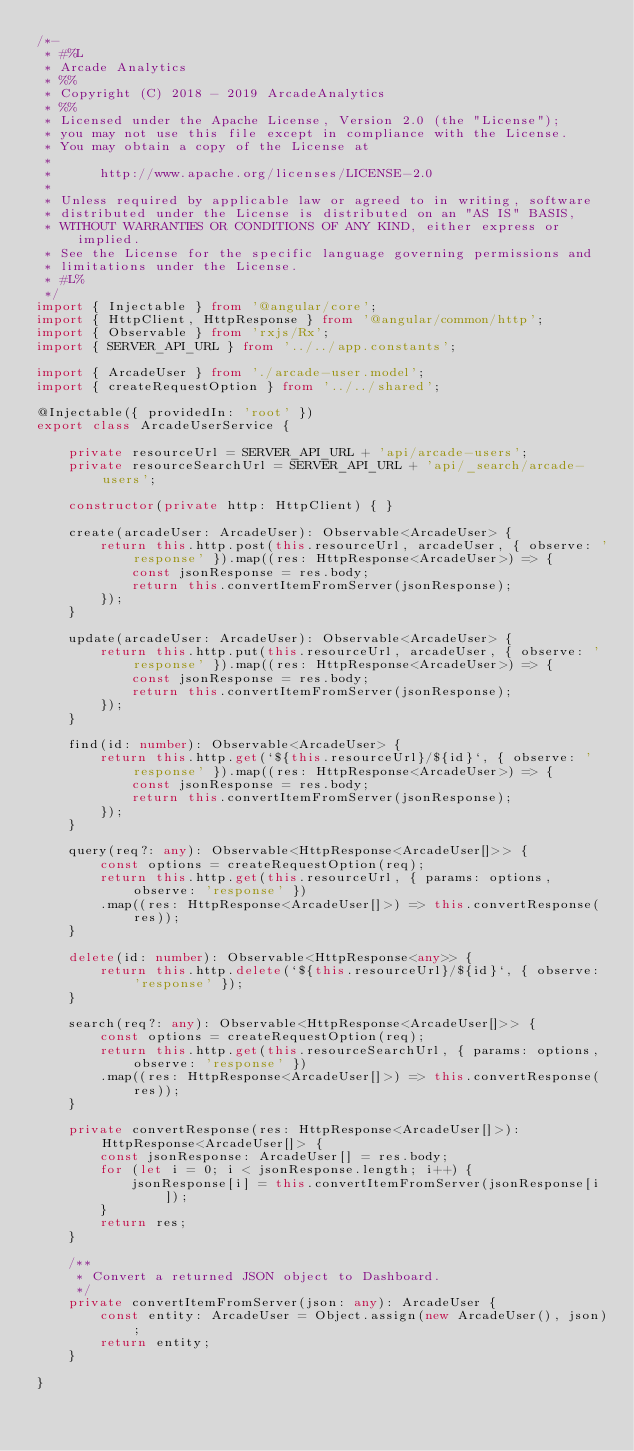<code> <loc_0><loc_0><loc_500><loc_500><_TypeScript_>/*-
 * #%L
 * Arcade Analytics
 * %%
 * Copyright (C) 2018 - 2019 ArcadeAnalytics
 * %%
 * Licensed under the Apache License, Version 2.0 (the "License");
 * you may not use this file except in compliance with the License.
 * You may obtain a copy of the License at
 *
 *      http://www.apache.org/licenses/LICENSE-2.0
 *
 * Unless required by applicable law or agreed to in writing, software
 * distributed under the License is distributed on an "AS IS" BASIS,
 * WITHOUT WARRANTIES OR CONDITIONS OF ANY KIND, either express or implied.
 * See the License for the specific language governing permissions and
 * limitations under the License.
 * #L%
 */
import { Injectable } from '@angular/core';
import { HttpClient, HttpResponse } from '@angular/common/http';
import { Observable } from 'rxjs/Rx';
import { SERVER_API_URL } from '../../app.constants';

import { ArcadeUser } from './arcade-user.model';
import { createRequestOption } from '../../shared';

@Injectable({ providedIn: 'root' })
export class ArcadeUserService {

    private resourceUrl = SERVER_API_URL + 'api/arcade-users';
    private resourceSearchUrl = SERVER_API_URL + 'api/_search/arcade-users';

    constructor(private http: HttpClient) { }

    create(arcadeUser: ArcadeUser): Observable<ArcadeUser> {
        return this.http.post(this.resourceUrl, arcadeUser, { observe: 'response' }).map((res: HttpResponse<ArcadeUser>) => {
            const jsonResponse = res.body;
            return this.convertItemFromServer(jsonResponse);
        });
    }

    update(arcadeUser: ArcadeUser): Observable<ArcadeUser> {
        return this.http.put(this.resourceUrl, arcadeUser, { observe: 'response' }).map((res: HttpResponse<ArcadeUser>) => {
            const jsonResponse = res.body;
            return this.convertItemFromServer(jsonResponse);
        });
    }

    find(id: number): Observable<ArcadeUser> {
        return this.http.get(`${this.resourceUrl}/${id}`, { observe: 'response' }).map((res: HttpResponse<ArcadeUser>) => {
            const jsonResponse = res.body;
            return this.convertItemFromServer(jsonResponse);
        });
    }

    query(req?: any): Observable<HttpResponse<ArcadeUser[]>> {
        const options = createRequestOption(req);
        return this.http.get(this.resourceUrl, { params: options, observe: 'response' })
        .map((res: HttpResponse<ArcadeUser[]>) => this.convertResponse(res));
    }

    delete(id: number): Observable<HttpResponse<any>> {
        return this.http.delete(`${this.resourceUrl}/${id}`, { observe: 'response' });
    }

    search(req?: any): Observable<HttpResponse<ArcadeUser[]>> {
        const options = createRequestOption(req);
        return this.http.get(this.resourceSearchUrl, { params: options, observe: 'response' })
        .map((res: HttpResponse<ArcadeUser[]>) => this.convertResponse(res));
    }

    private convertResponse(res: HttpResponse<ArcadeUser[]>): HttpResponse<ArcadeUser[]> {
        const jsonResponse: ArcadeUser[] = res.body;
        for (let i = 0; i < jsonResponse.length; i++) {
            jsonResponse[i] = this.convertItemFromServer(jsonResponse[i]);
        }
        return res;
    }

    /**
     * Convert a returned JSON object to Dashboard.
     */
    private convertItemFromServer(json: any): ArcadeUser {
        const entity: ArcadeUser = Object.assign(new ArcadeUser(), json);
        return entity;
    }

}
</code> 